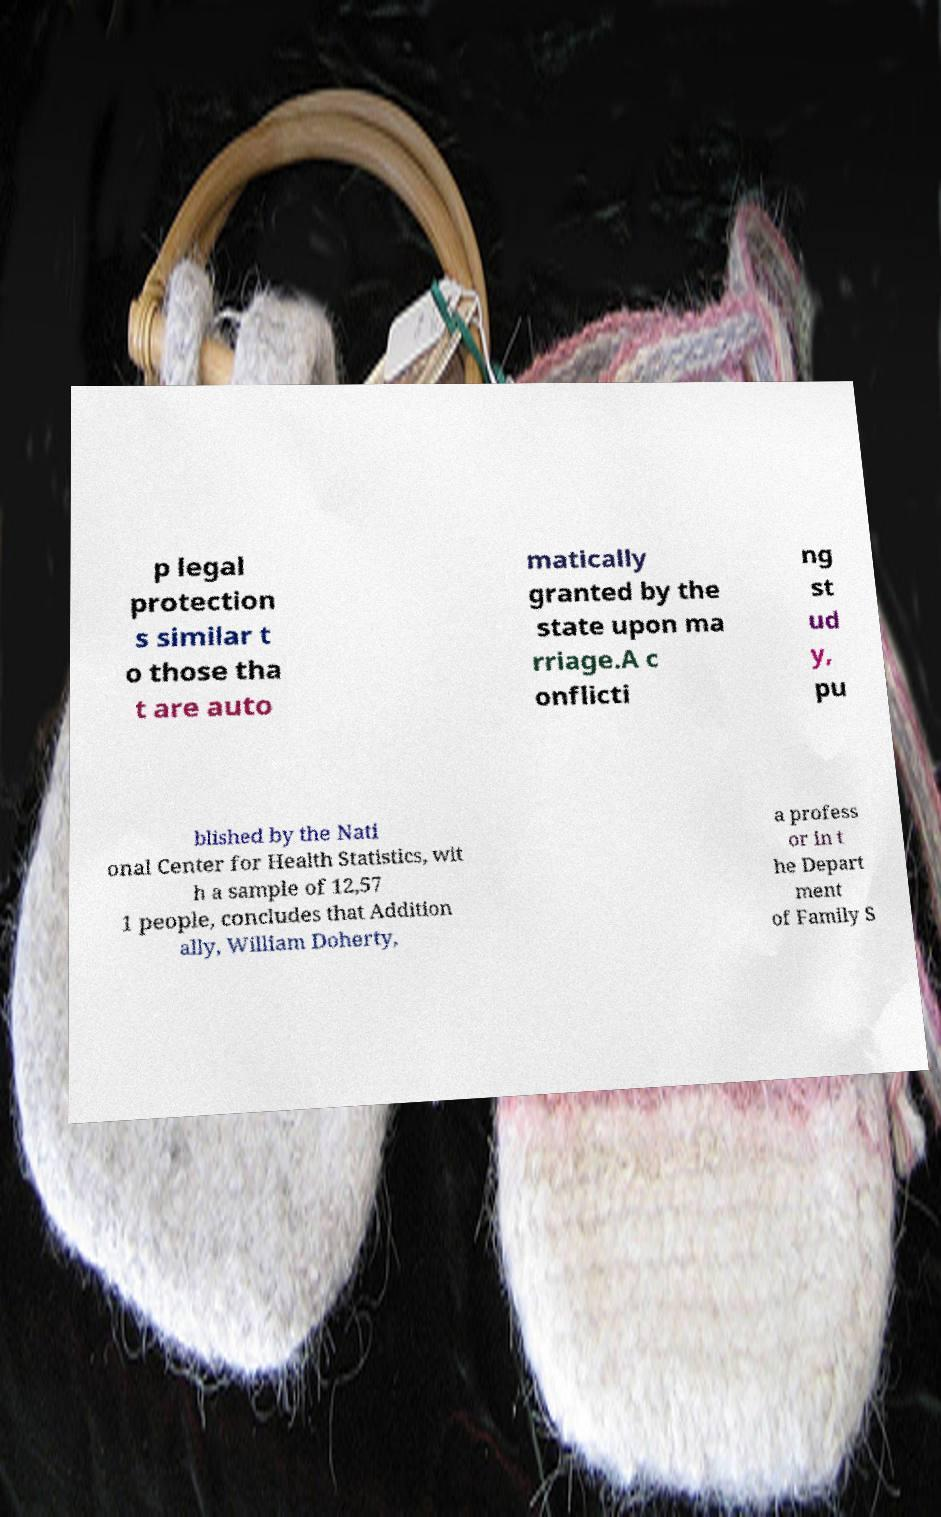Please read and relay the text visible in this image. What does it say? p legal protection s similar t o those tha t are auto matically granted by the state upon ma rriage.A c onflicti ng st ud y, pu blished by the Nati onal Center for Health Statistics, wit h a sample of 12,57 1 people, concludes that Addition ally, William Doherty, a profess or in t he Depart ment of Family S 